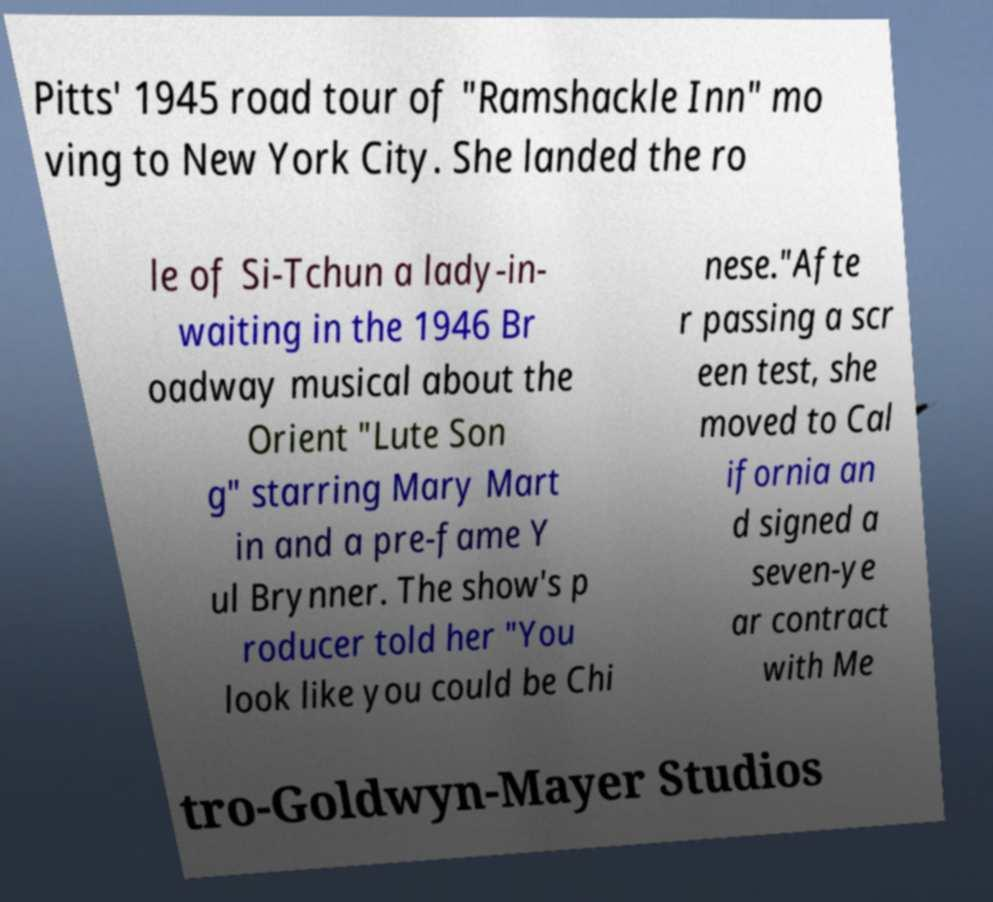Could you extract and type out the text from this image? Pitts' 1945 road tour of "Ramshackle Inn" mo ving to New York City. She landed the ro le of Si-Tchun a lady-in- waiting in the 1946 Br oadway musical about the Orient "Lute Son g" starring Mary Mart in and a pre-fame Y ul Brynner. The show's p roducer told her "You look like you could be Chi nese."Afte r passing a scr een test, she moved to Cal ifornia an d signed a seven-ye ar contract with Me tro-Goldwyn-Mayer Studios 